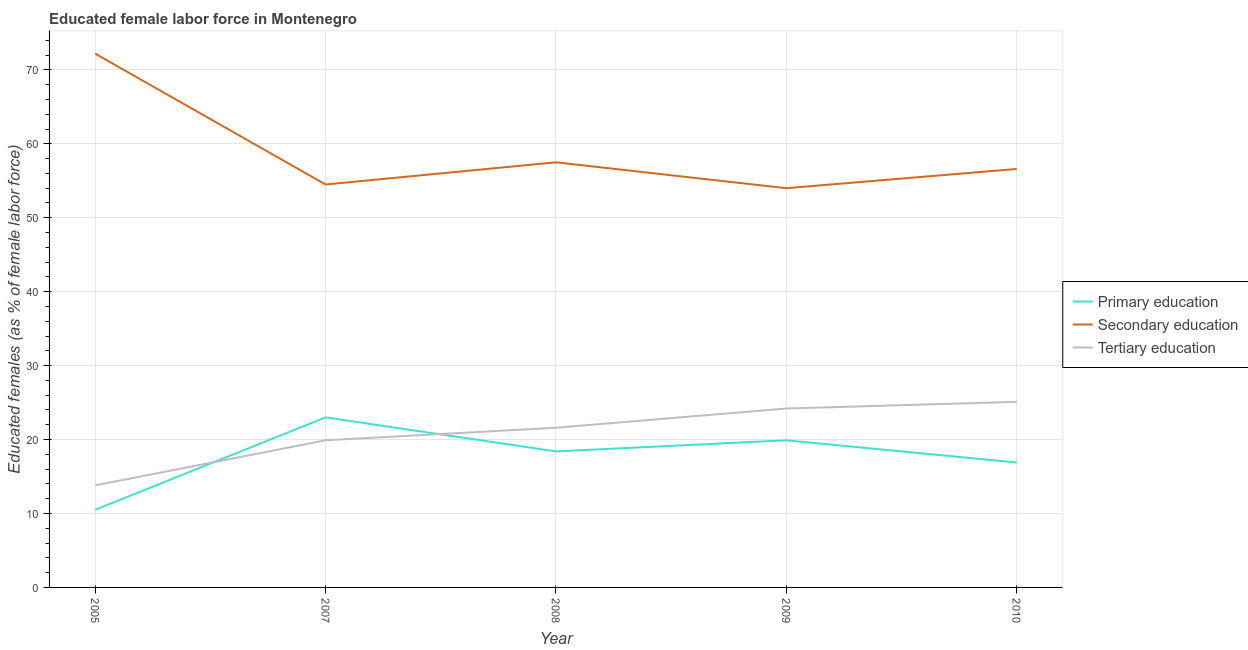How many different coloured lines are there?
Provide a succinct answer. 3. Does the line corresponding to percentage of female labor force who received primary education intersect with the line corresponding to percentage of female labor force who received secondary education?
Provide a short and direct response. No. What is the percentage of female labor force who received tertiary education in 2009?
Offer a very short reply. 24.2. Across all years, what is the maximum percentage of female labor force who received tertiary education?
Your answer should be very brief. 25.1. Across all years, what is the minimum percentage of female labor force who received tertiary education?
Offer a terse response. 13.8. What is the total percentage of female labor force who received secondary education in the graph?
Provide a short and direct response. 294.8. What is the difference between the percentage of female labor force who received tertiary education in 2008 and that in 2009?
Offer a very short reply. -2.6. What is the difference between the percentage of female labor force who received primary education in 2007 and the percentage of female labor force who received tertiary education in 2009?
Make the answer very short. -1.2. What is the average percentage of female labor force who received tertiary education per year?
Offer a very short reply. 20.92. In the year 2007, what is the difference between the percentage of female labor force who received tertiary education and percentage of female labor force who received secondary education?
Ensure brevity in your answer.  -34.6. What is the ratio of the percentage of female labor force who received secondary education in 2008 to that in 2010?
Offer a very short reply. 1.02. Is the percentage of female labor force who received tertiary education in 2007 less than that in 2010?
Keep it short and to the point. Yes. Is the difference between the percentage of female labor force who received primary education in 2005 and 2009 greater than the difference between the percentage of female labor force who received tertiary education in 2005 and 2009?
Offer a very short reply. Yes. What is the difference between the highest and the second highest percentage of female labor force who received tertiary education?
Your answer should be compact. 0.9. What is the difference between the highest and the lowest percentage of female labor force who received secondary education?
Offer a very short reply. 18.2. Is the sum of the percentage of female labor force who received secondary education in 2005 and 2010 greater than the maximum percentage of female labor force who received primary education across all years?
Provide a succinct answer. Yes. Does the percentage of female labor force who received secondary education monotonically increase over the years?
Ensure brevity in your answer.  No. Is the percentage of female labor force who received tertiary education strictly greater than the percentage of female labor force who received secondary education over the years?
Keep it short and to the point. No. Is the percentage of female labor force who received secondary education strictly less than the percentage of female labor force who received tertiary education over the years?
Provide a succinct answer. No. How many lines are there?
Give a very brief answer. 3. How many years are there in the graph?
Ensure brevity in your answer.  5. Does the graph contain any zero values?
Make the answer very short. No. Does the graph contain grids?
Offer a terse response. Yes. How many legend labels are there?
Provide a succinct answer. 3. How are the legend labels stacked?
Keep it short and to the point. Vertical. What is the title of the graph?
Your answer should be very brief. Educated female labor force in Montenegro. What is the label or title of the X-axis?
Your answer should be very brief. Year. What is the label or title of the Y-axis?
Keep it short and to the point. Educated females (as % of female labor force). What is the Educated females (as % of female labor force) of Secondary education in 2005?
Your response must be concise. 72.2. What is the Educated females (as % of female labor force) in Tertiary education in 2005?
Offer a terse response. 13.8. What is the Educated females (as % of female labor force) of Secondary education in 2007?
Your answer should be compact. 54.5. What is the Educated females (as % of female labor force) of Tertiary education in 2007?
Your response must be concise. 19.9. What is the Educated females (as % of female labor force) in Primary education in 2008?
Provide a succinct answer. 18.4. What is the Educated females (as % of female labor force) of Secondary education in 2008?
Provide a succinct answer. 57.5. What is the Educated females (as % of female labor force) in Tertiary education in 2008?
Keep it short and to the point. 21.6. What is the Educated females (as % of female labor force) of Primary education in 2009?
Provide a short and direct response. 19.9. What is the Educated females (as % of female labor force) of Secondary education in 2009?
Give a very brief answer. 54. What is the Educated females (as % of female labor force) in Tertiary education in 2009?
Ensure brevity in your answer.  24.2. What is the Educated females (as % of female labor force) in Primary education in 2010?
Keep it short and to the point. 16.9. What is the Educated females (as % of female labor force) of Secondary education in 2010?
Make the answer very short. 56.6. What is the Educated females (as % of female labor force) in Tertiary education in 2010?
Your answer should be compact. 25.1. Across all years, what is the maximum Educated females (as % of female labor force) in Primary education?
Your answer should be very brief. 23. Across all years, what is the maximum Educated females (as % of female labor force) in Secondary education?
Offer a terse response. 72.2. Across all years, what is the maximum Educated females (as % of female labor force) in Tertiary education?
Make the answer very short. 25.1. Across all years, what is the minimum Educated females (as % of female labor force) in Primary education?
Make the answer very short. 10.5. Across all years, what is the minimum Educated females (as % of female labor force) in Tertiary education?
Offer a very short reply. 13.8. What is the total Educated females (as % of female labor force) of Primary education in the graph?
Provide a succinct answer. 88.7. What is the total Educated females (as % of female labor force) of Secondary education in the graph?
Your response must be concise. 294.8. What is the total Educated females (as % of female labor force) of Tertiary education in the graph?
Keep it short and to the point. 104.6. What is the difference between the Educated females (as % of female labor force) of Primary education in 2005 and that in 2007?
Your answer should be very brief. -12.5. What is the difference between the Educated females (as % of female labor force) in Secondary education in 2005 and that in 2007?
Make the answer very short. 17.7. What is the difference between the Educated females (as % of female labor force) of Tertiary education in 2005 and that in 2008?
Keep it short and to the point. -7.8. What is the difference between the Educated females (as % of female labor force) of Primary education in 2007 and that in 2008?
Provide a succinct answer. 4.6. What is the difference between the Educated females (as % of female labor force) in Tertiary education in 2007 and that in 2008?
Your answer should be very brief. -1.7. What is the difference between the Educated females (as % of female labor force) of Secondary education in 2007 and that in 2009?
Your answer should be compact. 0.5. What is the difference between the Educated females (as % of female labor force) of Secondary education in 2007 and that in 2010?
Your response must be concise. -2.1. What is the difference between the Educated females (as % of female labor force) of Primary education in 2008 and that in 2009?
Offer a terse response. -1.5. What is the difference between the Educated females (as % of female labor force) of Secondary education in 2008 and that in 2009?
Make the answer very short. 3.5. What is the difference between the Educated females (as % of female labor force) in Tertiary education in 2008 and that in 2009?
Make the answer very short. -2.6. What is the difference between the Educated females (as % of female labor force) of Primary education in 2008 and that in 2010?
Provide a short and direct response. 1.5. What is the difference between the Educated females (as % of female labor force) of Secondary education in 2008 and that in 2010?
Your response must be concise. 0.9. What is the difference between the Educated females (as % of female labor force) in Tertiary education in 2008 and that in 2010?
Give a very brief answer. -3.5. What is the difference between the Educated females (as % of female labor force) in Primary education in 2009 and that in 2010?
Give a very brief answer. 3. What is the difference between the Educated females (as % of female labor force) in Primary education in 2005 and the Educated females (as % of female labor force) in Secondary education in 2007?
Ensure brevity in your answer.  -44. What is the difference between the Educated females (as % of female labor force) of Primary education in 2005 and the Educated females (as % of female labor force) of Tertiary education in 2007?
Ensure brevity in your answer.  -9.4. What is the difference between the Educated females (as % of female labor force) in Secondary education in 2005 and the Educated females (as % of female labor force) in Tertiary education in 2007?
Offer a terse response. 52.3. What is the difference between the Educated females (as % of female labor force) of Primary education in 2005 and the Educated females (as % of female labor force) of Secondary education in 2008?
Keep it short and to the point. -47. What is the difference between the Educated females (as % of female labor force) of Secondary education in 2005 and the Educated females (as % of female labor force) of Tertiary education in 2008?
Your answer should be very brief. 50.6. What is the difference between the Educated females (as % of female labor force) in Primary education in 2005 and the Educated females (as % of female labor force) in Secondary education in 2009?
Your answer should be compact. -43.5. What is the difference between the Educated females (as % of female labor force) of Primary education in 2005 and the Educated females (as % of female labor force) of Tertiary education in 2009?
Ensure brevity in your answer.  -13.7. What is the difference between the Educated females (as % of female labor force) of Secondary education in 2005 and the Educated females (as % of female labor force) of Tertiary education in 2009?
Ensure brevity in your answer.  48. What is the difference between the Educated females (as % of female labor force) in Primary education in 2005 and the Educated females (as % of female labor force) in Secondary education in 2010?
Provide a succinct answer. -46.1. What is the difference between the Educated females (as % of female labor force) of Primary education in 2005 and the Educated females (as % of female labor force) of Tertiary education in 2010?
Provide a succinct answer. -14.6. What is the difference between the Educated females (as % of female labor force) in Secondary education in 2005 and the Educated females (as % of female labor force) in Tertiary education in 2010?
Give a very brief answer. 47.1. What is the difference between the Educated females (as % of female labor force) in Primary education in 2007 and the Educated females (as % of female labor force) in Secondary education in 2008?
Give a very brief answer. -34.5. What is the difference between the Educated females (as % of female labor force) in Secondary education in 2007 and the Educated females (as % of female labor force) in Tertiary education in 2008?
Give a very brief answer. 32.9. What is the difference between the Educated females (as % of female labor force) in Primary education in 2007 and the Educated females (as % of female labor force) in Secondary education in 2009?
Your answer should be very brief. -31. What is the difference between the Educated females (as % of female labor force) in Primary education in 2007 and the Educated females (as % of female labor force) in Tertiary education in 2009?
Your response must be concise. -1.2. What is the difference between the Educated females (as % of female labor force) in Secondary education in 2007 and the Educated females (as % of female labor force) in Tertiary education in 2009?
Your response must be concise. 30.3. What is the difference between the Educated females (as % of female labor force) in Primary education in 2007 and the Educated females (as % of female labor force) in Secondary education in 2010?
Your answer should be very brief. -33.6. What is the difference between the Educated females (as % of female labor force) in Primary education in 2007 and the Educated females (as % of female labor force) in Tertiary education in 2010?
Keep it short and to the point. -2.1. What is the difference between the Educated females (as % of female labor force) in Secondary education in 2007 and the Educated females (as % of female labor force) in Tertiary education in 2010?
Provide a short and direct response. 29.4. What is the difference between the Educated females (as % of female labor force) of Primary education in 2008 and the Educated females (as % of female labor force) of Secondary education in 2009?
Make the answer very short. -35.6. What is the difference between the Educated females (as % of female labor force) in Primary education in 2008 and the Educated females (as % of female labor force) in Tertiary education in 2009?
Your answer should be very brief. -5.8. What is the difference between the Educated females (as % of female labor force) in Secondary education in 2008 and the Educated females (as % of female labor force) in Tertiary education in 2009?
Offer a very short reply. 33.3. What is the difference between the Educated females (as % of female labor force) of Primary education in 2008 and the Educated females (as % of female labor force) of Secondary education in 2010?
Ensure brevity in your answer.  -38.2. What is the difference between the Educated females (as % of female labor force) of Secondary education in 2008 and the Educated females (as % of female labor force) of Tertiary education in 2010?
Offer a terse response. 32.4. What is the difference between the Educated females (as % of female labor force) in Primary education in 2009 and the Educated females (as % of female labor force) in Secondary education in 2010?
Your answer should be compact. -36.7. What is the difference between the Educated females (as % of female labor force) of Secondary education in 2009 and the Educated females (as % of female labor force) of Tertiary education in 2010?
Your answer should be very brief. 28.9. What is the average Educated females (as % of female labor force) in Primary education per year?
Provide a succinct answer. 17.74. What is the average Educated females (as % of female labor force) in Secondary education per year?
Your answer should be compact. 58.96. What is the average Educated females (as % of female labor force) in Tertiary education per year?
Provide a succinct answer. 20.92. In the year 2005, what is the difference between the Educated females (as % of female labor force) of Primary education and Educated females (as % of female labor force) of Secondary education?
Offer a terse response. -61.7. In the year 2005, what is the difference between the Educated females (as % of female labor force) in Primary education and Educated females (as % of female labor force) in Tertiary education?
Keep it short and to the point. -3.3. In the year 2005, what is the difference between the Educated females (as % of female labor force) in Secondary education and Educated females (as % of female labor force) in Tertiary education?
Your response must be concise. 58.4. In the year 2007, what is the difference between the Educated females (as % of female labor force) in Primary education and Educated females (as % of female labor force) in Secondary education?
Keep it short and to the point. -31.5. In the year 2007, what is the difference between the Educated females (as % of female labor force) of Primary education and Educated females (as % of female labor force) of Tertiary education?
Make the answer very short. 3.1. In the year 2007, what is the difference between the Educated females (as % of female labor force) of Secondary education and Educated females (as % of female labor force) of Tertiary education?
Your response must be concise. 34.6. In the year 2008, what is the difference between the Educated females (as % of female labor force) of Primary education and Educated females (as % of female labor force) of Secondary education?
Make the answer very short. -39.1. In the year 2008, what is the difference between the Educated females (as % of female labor force) of Primary education and Educated females (as % of female labor force) of Tertiary education?
Your response must be concise. -3.2. In the year 2008, what is the difference between the Educated females (as % of female labor force) in Secondary education and Educated females (as % of female labor force) in Tertiary education?
Offer a very short reply. 35.9. In the year 2009, what is the difference between the Educated females (as % of female labor force) in Primary education and Educated females (as % of female labor force) in Secondary education?
Your answer should be compact. -34.1. In the year 2009, what is the difference between the Educated females (as % of female labor force) of Secondary education and Educated females (as % of female labor force) of Tertiary education?
Your answer should be very brief. 29.8. In the year 2010, what is the difference between the Educated females (as % of female labor force) of Primary education and Educated females (as % of female labor force) of Secondary education?
Give a very brief answer. -39.7. In the year 2010, what is the difference between the Educated females (as % of female labor force) in Secondary education and Educated females (as % of female labor force) in Tertiary education?
Your response must be concise. 31.5. What is the ratio of the Educated females (as % of female labor force) in Primary education in 2005 to that in 2007?
Your answer should be very brief. 0.46. What is the ratio of the Educated females (as % of female labor force) in Secondary education in 2005 to that in 2007?
Provide a succinct answer. 1.32. What is the ratio of the Educated females (as % of female labor force) in Tertiary education in 2005 to that in 2007?
Provide a short and direct response. 0.69. What is the ratio of the Educated females (as % of female labor force) of Primary education in 2005 to that in 2008?
Make the answer very short. 0.57. What is the ratio of the Educated females (as % of female labor force) of Secondary education in 2005 to that in 2008?
Give a very brief answer. 1.26. What is the ratio of the Educated females (as % of female labor force) in Tertiary education in 2005 to that in 2008?
Your answer should be very brief. 0.64. What is the ratio of the Educated females (as % of female labor force) of Primary education in 2005 to that in 2009?
Keep it short and to the point. 0.53. What is the ratio of the Educated females (as % of female labor force) in Secondary education in 2005 to that in 2009?
Give a very brief answer. 1.34. What is the ratio of the Educated females (as % of female labor force) of Tertiary education in 2005 to that in 2009?
Your answer should be compact. 0.57. What is the ratio of the Educated females (as % of female labor force) of Primary education in 2005 to that in 2010?
Provide a short and direct response. 0.62. What is the ratio of the Educated females (as % of female labor force) in Secondary education in 2005 to that in 2010?
Offer a terse response. 1.28. What is the ratio of the Educated females (as % of female labor force) of Tertiary education in 2005 to that in 2010?
Keep it short and to the point. 0.55. What is the ratio of the Educated females (as % of female labor force) of Primary education in 2007 to that in 2008?
Ensure brevity in your answer.  1.25. What is the ratio of the Educated females (as % of female labor force) of Secondary education in 2007 to that in 2008?
Give a very brief answer. 0.95. What is the ratio of the Educated females (as % of female labor force) in Tertiary education in 2007 to that in 2008?
Your answer should be very brief. 0.92. What is the ratio of the Educated females (as % of female labor force) in Primary education in 2007 to that in 2009?
Give a very brief answer. 1.16. What is the ratio of the Educated females (as % of female labor force) of Secondary education in 2007 to that in 2009?
Your answer should be very brief. 1.01. What is the ratio of the Educated females (as % of female labor force) of Tertiary education in 2007 to that in 2009?
Ensure brevity in your answer.  0.82. What is the ratio of the Educated females (as % of female labor force) in Primary education in 2007 to that in 2010?
Give a very brief answer. 1.36. What is the ratio of the Educated females (as % of female labor force) of Secondary education in 2007 to that in 2010?
Ensure brevity in your answer.  0.96. What is the ratio of the Educated females (as % of female labor force) in Tertiary education in 2007 to that in 2010?
Provide a short and direct response. 0.79. What is the ratio of the Educated females (as % of female labor force) of Primary education in 2008 to that in 2009?
Give a very brief answer. 0.92. What is the ratio of the Educated females (as % of female labor force) of Secondary education in 2008 to that in 2009?
Ensure brevity in your answer.  1.06. What is the ratio of the Educated females (as % of female labor force) of Tertiary education in 2008 to that in 2009?
Your answer should be very brief. 0.89. What is the ratio of the Educated females (as % of female labor force) in Primary education in 2008 to that in 2010?
Your answer should be compact. 1.09. What is the ratio of the Educated females (as % of female labor force) of Secondary education in 2008 to that in 2010?
Your answer should be compact. 1.02. What is the ratio of the Educated females (as % of female labor force) in Tertiary education in 2008 to that in 2010?
Make the answer very short. 0.86. What is the ratio of the Educated females (as % of female labor force) of Primary education in 2009 to that in 2010?
Offer a very short reply. 1.18. What is the ratio of the Educated females (as % of female labor force) of Secondary education in 2009 to that in 2010?
Keep it short and to the point. 0.95. What is the ratio of the Educated females (as % of female labor force) in Tertiary education in 2009 to that in 2010?
Offer a terse response. 0.96. What is the difference between the highest and the second highest Educated females (as % of female labor force) of Primary education?
Ensure brevity in your answer.  3.1. What is the difference between the highest and the second highest Educated females (as % of female labor force) in Secondary education?
Offer a very short reply. 14.7. What is the difference between the highest and the second highest Educated females (as % of female labor force) of Tertiary education?
Keep it short and to the point. 0.9. What is the difference between the highest and the lowest Educated females (as % of female labor force) in Secondary education?
Give a very brief answer. 18.2. What is the difference between the highest and the lowest Educated females (as % of female labor force) of Tertiary education?
Offer a very short reply. 11.3. 